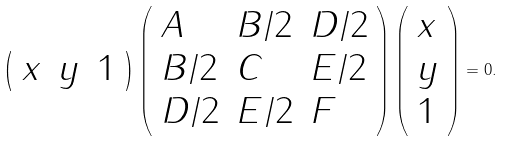<formula> <loc_0><loc_0><loc_500><loc_500>\left ( { \begin{array} { l l l } { x } & { y } & { 1 } \end{array} } \right ) \left ( { \begin{array} { l l l } { A } & { B / 2 } & { D / 2 } \\ { B / 2 } & { C } & { E / 2 } \\ { D / 2 } & { E / 2 } & { F } \end{array} } \right ) \left ( { \begin{array} { l } { x } \\ { y } \\ { 1 } \end{array} } \right ) = 0 .</formula> 